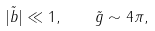Convert formula to latex. <formula><loc_0><loc_0><loc_500><loc_500>| \tilde { b } | \ll 1 , \quad \tilde { g } \sim 4 \pi ,</formula> 